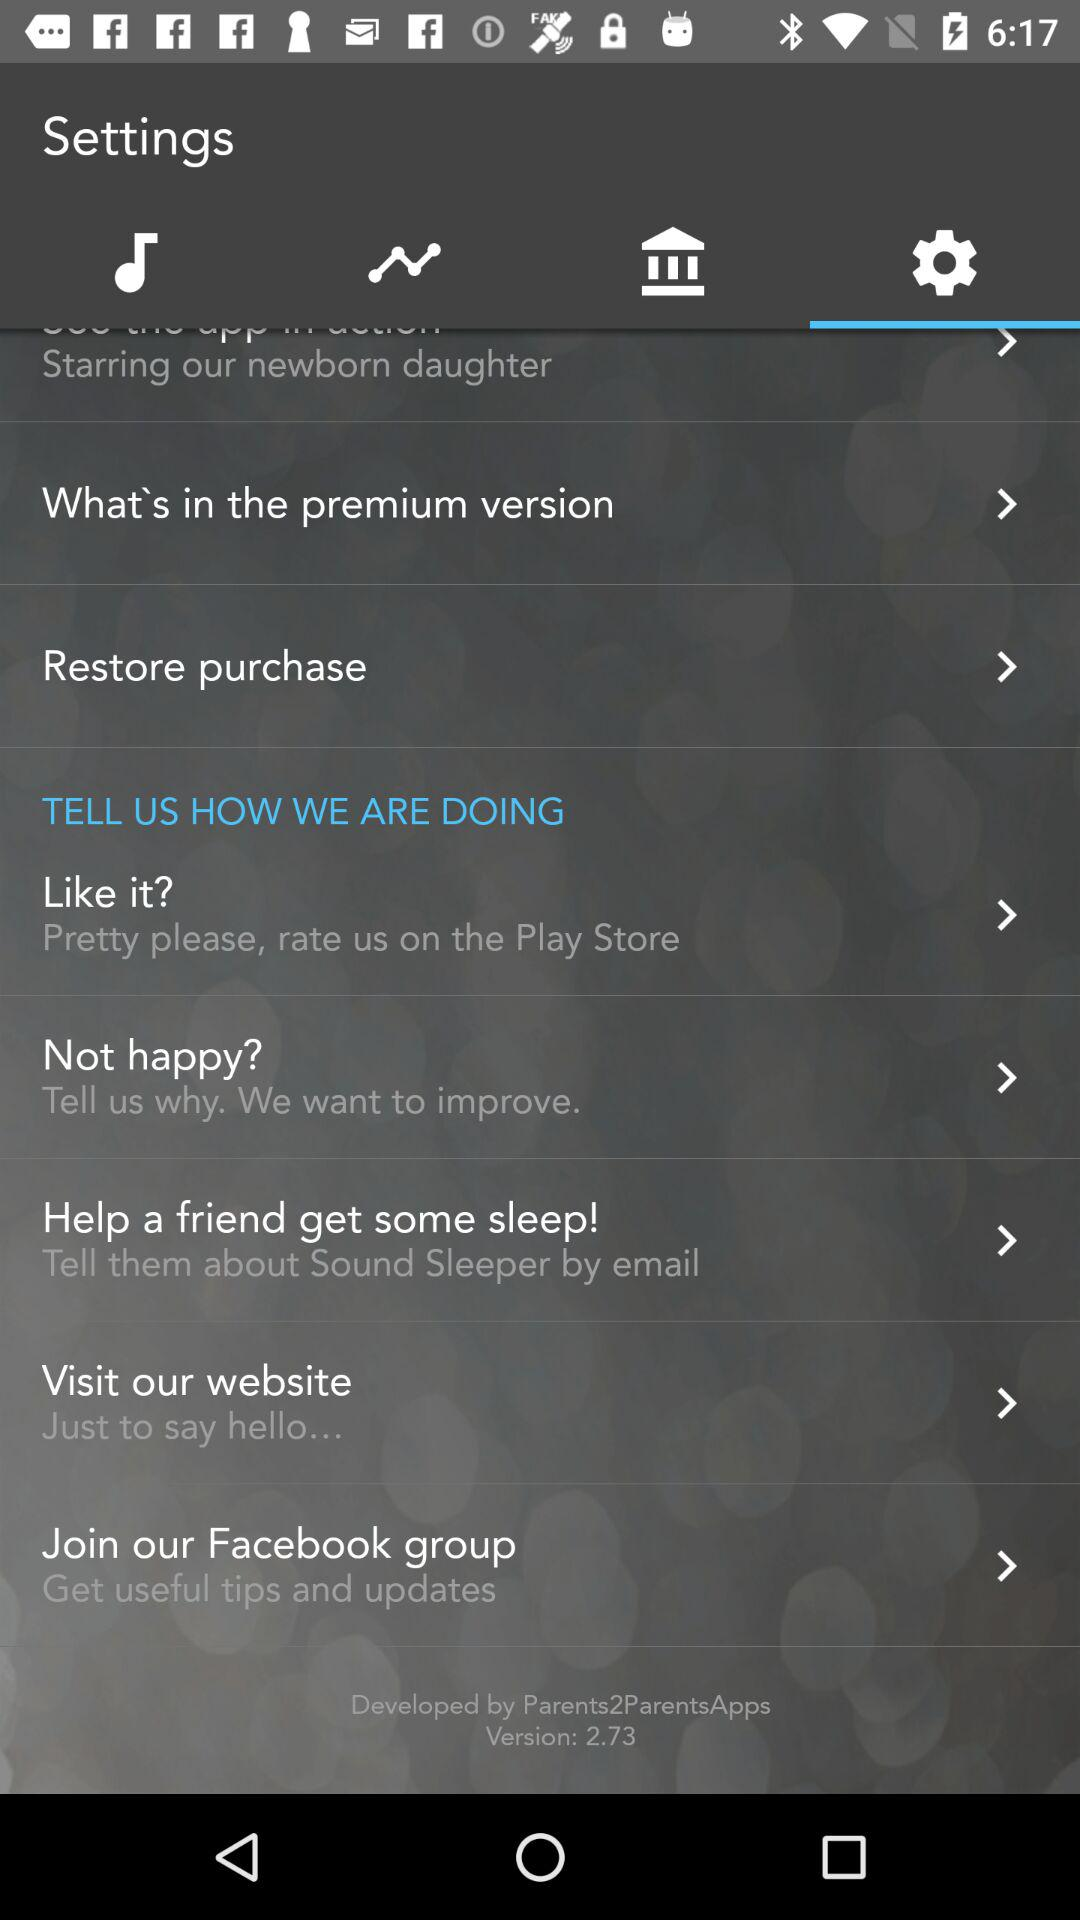What is the version number? The version number is 2.73. 